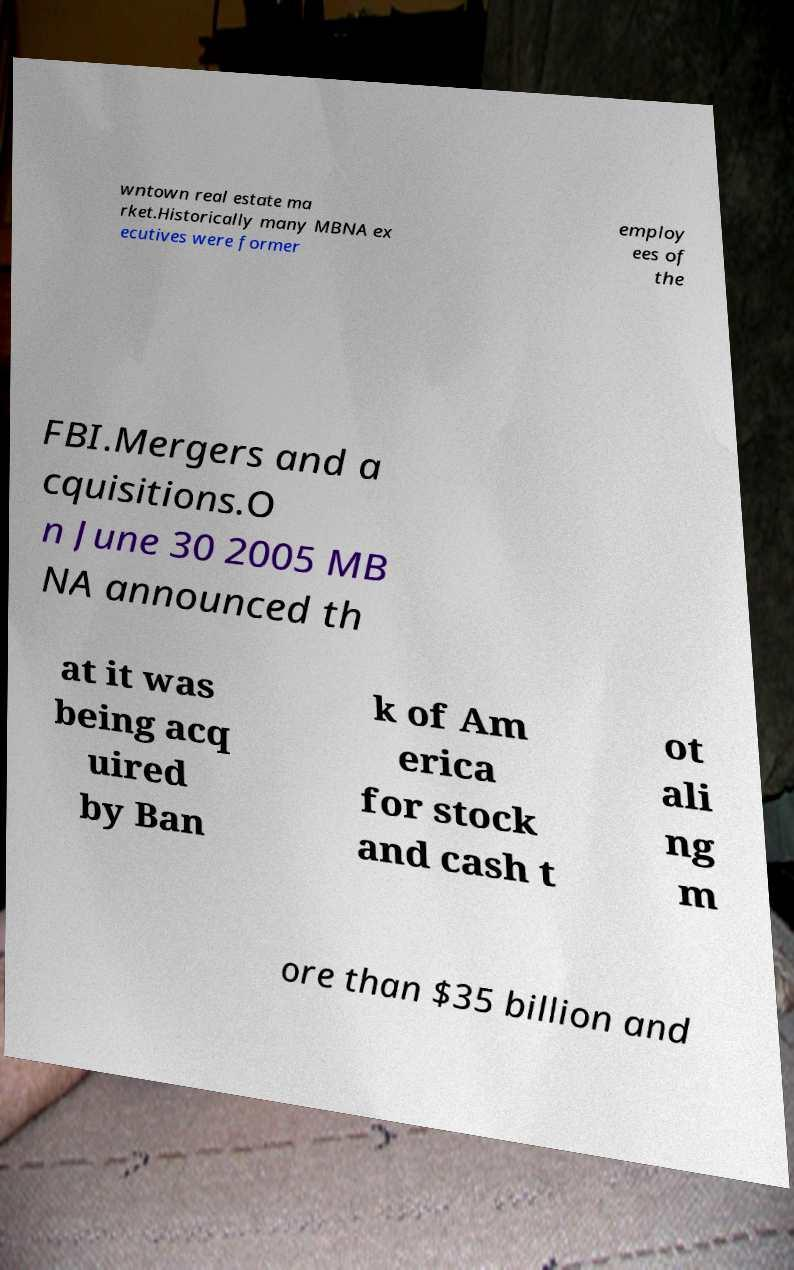What messages or text are displayed in this image? I need them in a readable, typed format. wntown real estate ma rket.Historically many MBNA ex ecutives were former employ ees of the FBI.Mergers and a cquisitions.O n June 30 2005 MB NA announced th at it was being acq uired by Ban k of Am erica for stock and cash t ot ali ng m ore than $35 billion and 